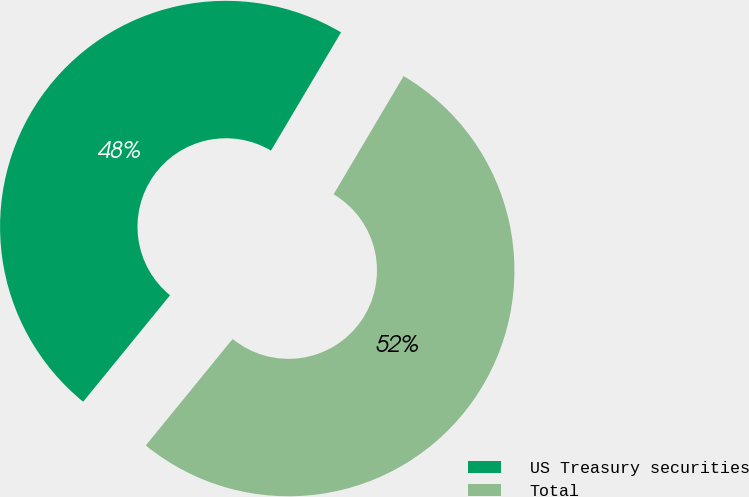Convert chart. <chart><loc_0><loc_0><loc_500><loc_500><pie_chart><fcel>US Treasury securities<fcel>Total<nl><fcel>47.62%<fcel>52.38%<nl></chart> 